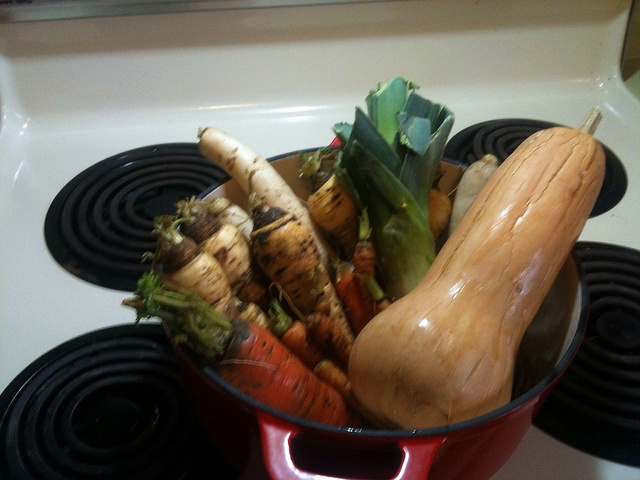Describe the objects in this image and their specific colors. I can see oven in black, darkgray, gray, and lightgray tones, bowl in black, maroon, olive, and tan tones, carrot in black, maroon, and brown tones, carrot in black, maroon, and olive tones, and carrot in black, olive, and tan tones in this image. 